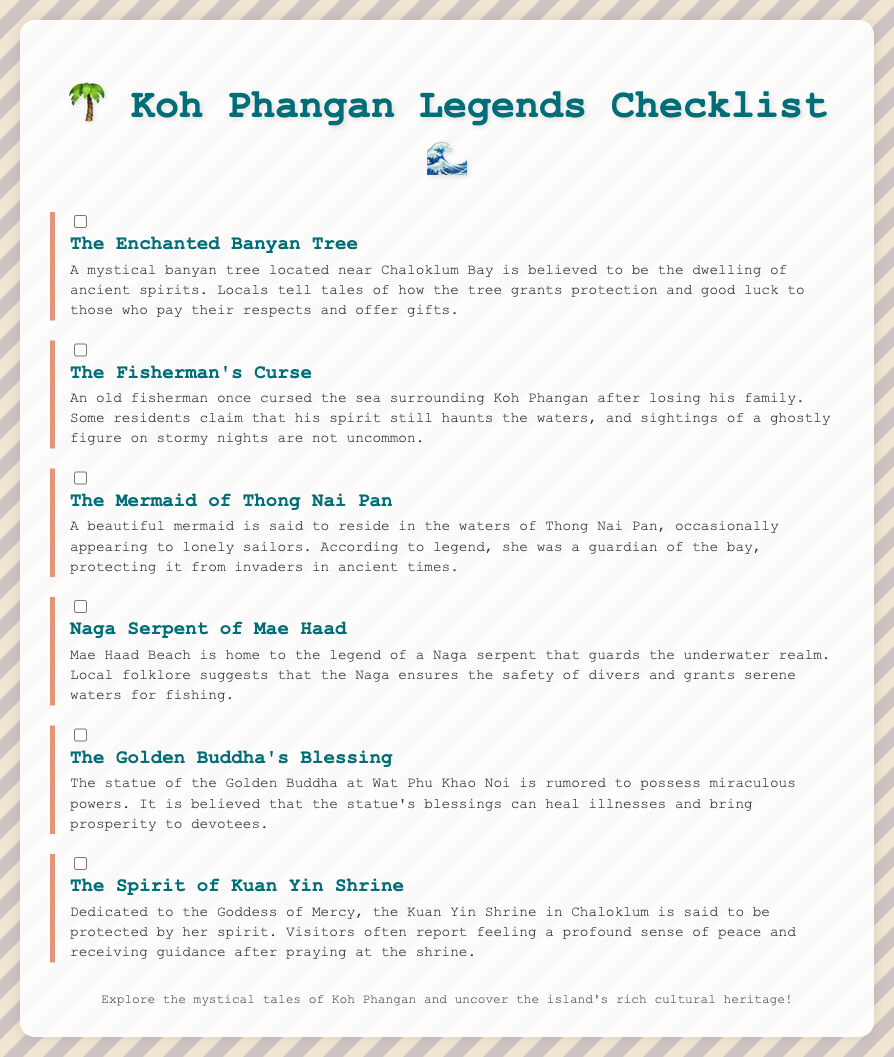What is the first legend listed? The first legend in the document is "The Enchanted Banyan Tree."
Answer: The Enchanted Banyan Tree How many legends are mentioned in the checklist? The document mentions a total of six legends.
Answer: 6 What is said to grant protection and good luck in the first legend? The mystical banyan tree grants protection and good luck to those who pay respects.
Answer: The mystical banyan tree Which legend is associated with Thong Nai Pan? "The Mermaid of Thong Nai Pan" is associated with Thong Nai Pan according to the document.
Answer: The Mermaid of Thong Nai Pan What is the magical statue mentioned in the checklist? The statue of the Golden Buddha at Wat Phu Khao Noi is mentioned as having miraculous powers.
Answer: The Golden Buddha What role does the Naga Serpent play in local folklore? The Naga Serpent is said to guard the underwater realm and ensure safety for divers.
Answer: Guards the underwater realm Which legend relates to a curse from an old fisherman? "The Fisherman's Curse" pertains to the curse from the old fisherman who lost his family.
Answer: The Fisherman's Curse What is the Kuan Yin Shrine dedicated to? The Kuan Yin Shrine is dedicated to the Goddess of Mercy according to the folklore.
Answer: Goddess of Mercy 